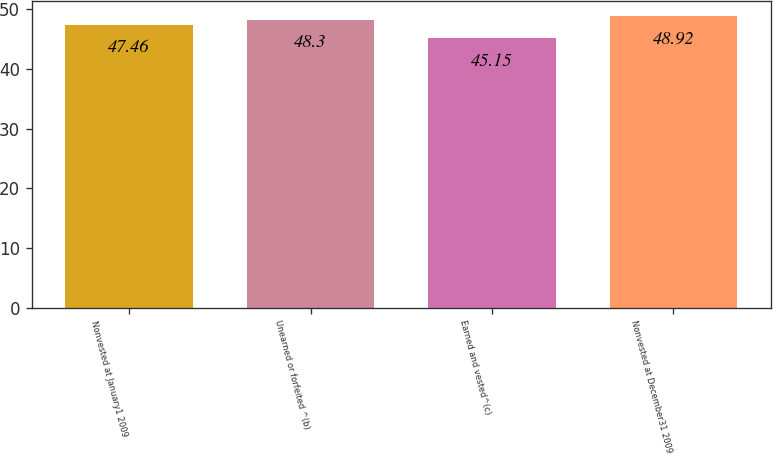<chart> <loc_0><loc_0><loc_500><loc_500><bar_chart><fcel>Nonvested at January1 2009<fcel>Unearned or forfeited ^(b)<fcel>Earned and vested^(c)<fcel>Nonvested at December31 2009<nl><fcel>47.46<fcel>48.3<fcel>45.15<fcel>48.92<nl></chart> 